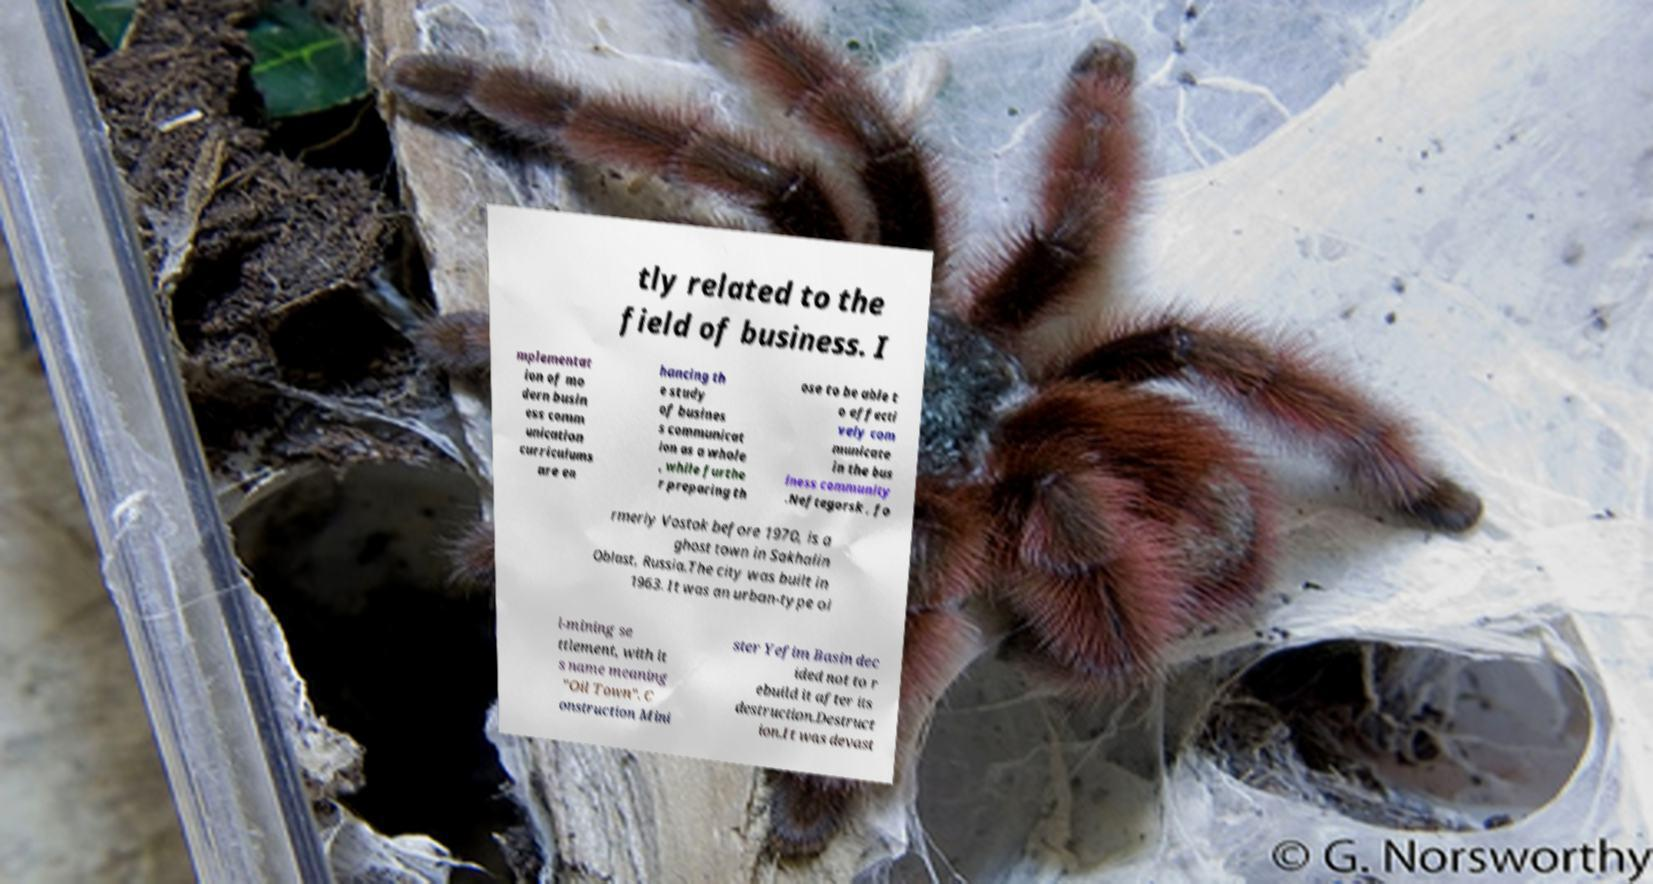What messages or text are displayed in this image? I need them in a readable, typed format. tly related to the field of business. I mplementat ion of mo dern busin ess comm unication curriculums are en hancing th e study of busines s communicat ion as a whole , while furthe r preparing th ose to be able t o effecti vely com municate in the bus iness community .Neftegorsk , fo rmerly Vostok before 1970, is a ghost town in Sakhalin Oblast, Russia.The city was built in 1963. It was an urban-type oi l-mining se ttlement, with it s name meaning "Oil Town". C onstruction Mini ster Yefim Basin dec ided not to r ebuild it after its destruction.Destruct ion.It was devast 